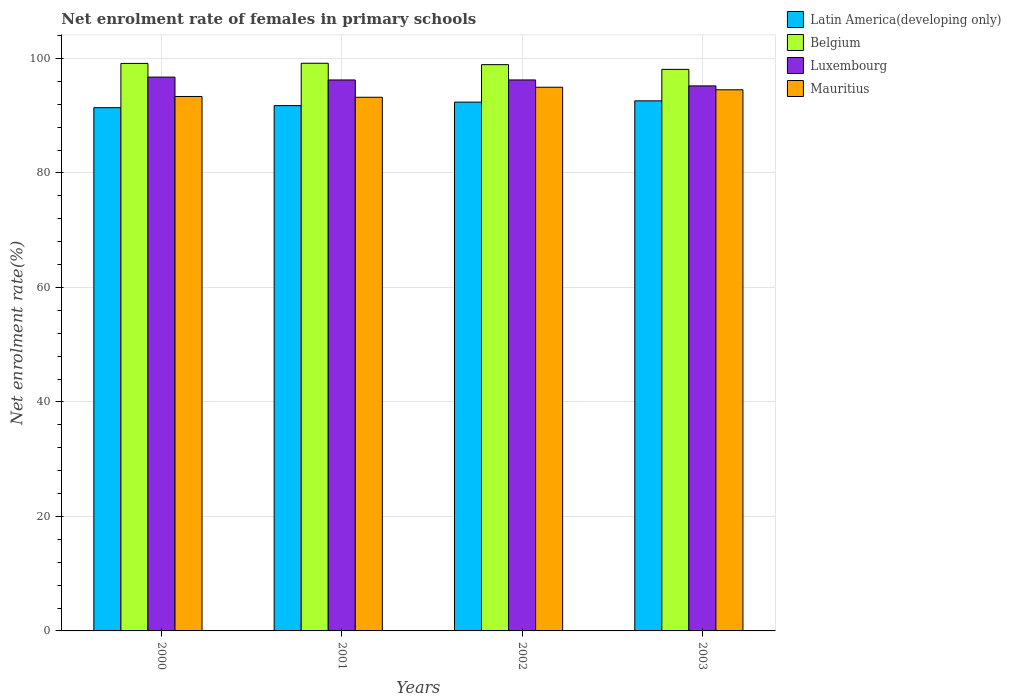Are the number of bars on each tick of the X-axis equal?
Your answer should be compact. Yes. What is the label of the 3rd group of bars from the left?
Offer a very short reply. 2002. In how many cases, is the number of bars for a given year not equal to the number of legend labels?
Provide a succinct answer. 0. What is the net enrolment rate of females in primary schools in Latin America(developing only) in 2001?
Make the answer very short. 91.77. Across all years, what is the maximum net enrolment rate of females in primary schools in Luxembourg?
Your answer should be compact. 96.75. Across all years, what is the minimum net enrolment rate of females in primary schools in Mauritius?
Offer a very short reply. 93.23. In which year was the net enrolment rate of females in primary schools in Mauritius minimum?
Provide a short and direct response. 2001. What is the total net enrolment rate of females in primary schools in Belgium in the graph?
Keep it short and to the point. 395.34. What is the difference between the net enrolment rate of females in primary schools in Mauritius in 2000 and that in 2002?
Make the answer very short. -1.61. What is the difference between the net enrolment rate of females in primary schools in Mauritius in 2000 and the net enrolment rate of females in primary schools in Luxembourg in 2003?
Your response must be concise. -1.85. What is the average net enrolment rate of females in primary schools in Mauritius per year?
Your response must be concise. 94.03. In the year 2002, what is the difference between the net enrolment rate of females in primary schools in Latin America(developing only) and net enrolment rate of females in primary schools in Luxembourg?
Your answer should be very brief. -3.88. In how many years, is the net enrolment rate of females in primary schools in Belgium greater than 24 %?
Ensure brevity in your answer.  4. What is the ratio of the net enrolment rate of females in primary schools in Belgium in 2001 to that in 2003?
Provide a short and direct response. 1.01. Is the difference between the net enrolment rate of females in primary schools in Latin America(developing only) in 2001 and 2003 greater than the difference between the net enrolment rate of females in primary schools in Luxembourg in 2001 and 2003?
Your answer should be compact. No. What is the difference between the highest and the second highest net enrolment rate of females in primary schools in Luxembourg?
Give a very brief answer. 0.5. What is the difference between the highest and the lowest net enrolment rate of females in primary schools in Luxembourg?
Your response must be concise. 1.54. Is the sum of the net enrolment rate of females in primary schools in Latin America(developing only) in 2000 and 2001 greater than the maximum net enrolment rate of females in primary schools in Luxembourg across all years?
Provide a short and direct response. Yes. Is it the case that in every year, the sum of the net enrolment rate of females in primary schools in Mauritius and net enrolment rate of females in primary schools in Belgium is greater than the sum of net enrolment rate of females in primary schools in Latin America(developing only) and net enrolment rate of females in primary schools in Luxembourg?
Your answer should be compact. Yes. What does the 1st bar from the left in 2003 represents?
Ensure brevity in your answer.  Latin America(developing only). What does the 4th bar from the right in 2003 represents?
Keep it short and to the point. Latin America(developing only). How many years are there in the graph?
Give a very brief answer. 4. What is the difference between two consecutive major ticks on the Y-axis?
Offer a very short reply. 20. Does the graph contain any zero values?
Offer a very short reply. No. Does the graph contain grids?
Provide a short and direct response. Yes. Where does the legend appear in the graph?
Give a very brief answer. Top right. What is the title of the graph?
Make the answer very short. Net enrolment rate of females in primary schools. What is the label or title of the X-axis?
Keep it short and to the point. Years. What is the label or title of the Y-axis?
Offer a very short reply. Net enrolment rate(%). What is the Net enrolment rate(%) in Latin America(developing only) in 2000?
Give a very brief answer. 91.41. What is the Net enrolment rate(%) in Belgium in 2000?
Provide a short and direct response. 99.14. What is the Net enrolment rate(%) in Luxembourg in 2000?
Your answer should be compact. 96.75. What is the Net enrolment rate(%) of Mauritius in 2000?
Ensure brevity in your answer.  93.36. What is the Net enrolment rate(%) in Latin America(developing only) in 2001?
Offer a very short reply. 91.77. What is the Net enrolment rate(%) of Belgium in 2001?
Your answer should be compact. 99.17. What is the Net enrolment rate(%) of Luxembourg in 2001?
Provide a succinct answer. 96.25. What is the Net enrolment rate(%) in Mauritius in 2001?
Your response must be concise. 93.23. What is the Net enrolment rate(%) in Latin America(developing only) in 2002?
Offer a very short reply. 92.38. What is the Net enrolment rate(%) in Belgium in 2002?
Your answer should be very brief. 98.93. What is the Net enrolment rate(%) in Luxembourg in 2002?
Make the answer very short. 96.25. What is the Net enrolment rate(%) of Mauritius in 2002?
Provide a short and direct response. 94.98. What is the Net enrolment rate(%) in Latin America(developing only) in 2003?
Offer a terse response. 92.6. What is the Net enrolment rate(%) of Belgium in 2003?
Your answer should be very brief. 98.1. What is the Net enrolment rate(%) in Luxembourg in 2003?
Ensure brevity in your answer.  95.21. What is the Net enrolment rate(%) in Mauritius in 2003?
Your answer should be very brief. 94.53. Across all years, what is the maximum Net enrolment rate(%) of Latin America(developing only)?
Offer a very short reply. 92.6. Across all years, what is the maximum Net enrolment rate(%) in Belgium?
Offer a very short reply. 99.17. Across all years, what is the maximum Net enrolment rate(%) of Luxembourg?
Offer a terse response. 96.75. Across all years, what is the maximum Net enrolment rate(%) in Mauritius?
Your answer should be compact. 94.98. Across all years, what is the minimum Net enrolment rate(%) of Latin America(developing only)?
Give a very brief answer. 91.41. Across all years, what is the minimum Net enrolment rate(%) in Belgium?
Provide a short and direct response. 98.1. Across all years, what is the minimum Net enrolment rate(%) of Luxembourg?
Offer a very short reply. 95.21. Across all years, what is the minimum Net enrolment rate(%) in Mauritius?
Provide a succinct answer. 93.23. What is the total Net enrolment rate(%) of Latin America(developing only) in the graph?
Your response must be concise. 368.15. What is the total Net enrolment rate(%) in Belgium in the graph?
Your answer should be compact. 395.34. What is the total Net enrolment rate(%) in Luxembourg in the graph?
Provide a short and direct response. 384.47. What is the total Net enrolment rate(%) of Mauritius in the graph?
Give a very brief answer. 376.11. What is the difference between the Net enrolment rate(%) of Latin America(developing only) in 2000 and that in 2001?
Your answer should be very brief. -0.36. What is the difference between the Net enrolment rate(%) in Belgium in 2000 and that in 2001?
Offer a very short reply. -0.03. What is the difference between the Net enrolment rate(%) of Luxembourg in 2000 and that in 2001?
Provide a short and direct response. 0.5. What is the difference between the Net enrolment rate(%) in Mauritius in 2000 and that in 2001?
Offer a terse response. 0.13. What is the difference between the Net enrolment rate(%) in Latin America(developing only) in 2000 and that in 2002?
Ensure brevity in your answer.  -0.97. What is the difference between the Net enrolment rate(%) of Belgium in 2000 and that in 2002?
Make the answer very short. 0.22. What is the difference between the Net enrolment rate(%) of Luxembourg in 2000 and that in 2002?
Keep it short and to the point. 0.5. What is the difference between the Net enrolment rate(%) of Mauritius in 2000 and that in 2002?
Give a very brief answer. -1.61. What is the difference between the Net enrolment rate(%) of Latin America(developing only) in 2000 and that in 2003?
Your answer should be compact. -1.2. What is the difference between the Net enrolment rate(%) in Belgium in 2000 and that in 2003?
Your answer should be very brief. 1.04. What is the difference between the Net enrolment rate(%) of Luxembourg in 2000 and that in 2003?
Offer a very short reply. 1.54. What is the difference between the Net enrolment rate(%) in Mauritius in 2000 and that in 2003?
Give a very brief answer. -1.17. What is the difference between the Net enrolment rate(%) in Latin America(developing only) in 2001 and that in 2002?
Provide a short and direct response. -0.61. What is the difference between the Net enrolment rate(%) in Belgium in 2001 and that in 2002?
Ensure brevity in your answer.  0.24. What is the difference between the Net enrolment rate(%) in Luxembourg in 2001 and that in 2002?
Offer a terse response. -0. What is the difference between the Net enrolment rate(%) in Mauritius in 2001 and that in 2002?
Offer a very short reply. -1.75. What is the difference between the Net enrolment rate(%) of Latin America(developing only) in 2001 and that in 2003?
Provide a short and direct response. -0.84. What is the difference between the Net enrolment rate(%) of Belgium in 2001 and that in 2003?
Provide a succinct answer. 1.07. What is the difference between the Net enrolment rate(%) in Luxembourg in 2001 and that in 2003?
Give a very brief answer. 1.04. What is the difference between the Net enrolment rate(%) in Mauritius in 2001 and that in 2003?
Your response must be concise. -1.3. What is the difference between the Net enrolment rate(%) in Latin America(developing only) in 2002 and that in 2003?
Provide a short and direct response. -0.22. What is the difference between the Net enrolment rate(%) of Belgium in 2002 and that in 2003?
Ensure brevity in your answer.  0.83. What is the difference between the Net enrolment rate(%) in Luxembourg in 2002 and that in 2003?
Your answer should be compact. 1.04. What is the difference between the Net enrolment rate(%) of Mauritius in 2002 and that in 2003?
Your answer should be compact. 0.44. What is the difference between the Net enrolment rate(%) of Latin America(developing only) in 2000 and the Net enrolment rate(%) of Belgium in 2001?
Your response must be concise. -7.76. What is the difference between the Net enrolment rate(%) in Latin America(developing only) in 2000 and the Net enrolment rate(%) in Luxembourg in 2001?
Provide a succinct answer. -4.85. What is the difference between the Net enrolment rate(%) of Latin America(developing only) in 2000 and the Net enrolment rate(%) of Mauritius in 2001?
Provide a succinct answer. -1.82. What is the difference between the Net enrolment rate(%) of Belgium in 2000 and the Net enrolment rate(%) of Luxembourg in 2001?
Provide a succinct answer. 2.89. What is the difference between the Net enrolment rate(%) of Belgium in 2000 and the Net enrolment rate(%) of Mauritius in 2001?
Your response must be concise. 5.91. What is the difference between the Net enrolment rate(%) of Luxembourg in 2000 and the Net enrolment rate(%) of Mauritius in 2001?
Provide a short and direct response. 3.52. What is the difference between the Net enrolment rate(%) of Latin America(developing only) in 2000 and the Net enrolment rate(%) of Belgium in 2002?
Your answer should be compact. -7.52. What is the difference between the Net enrolment rate(%) of Latin America(developing only) in 2000 and the Net enrolment rate(%) of Luxembourg in 2002?
Provide a succinct answer. -4.85. What is the difference between the Net enrolment rate(%) in Latin America(developing only) in 2000 and the Net enrolment rate(%) in Mauritius in 2002?
Your response must be concise. -3.57. What is the difference between the Net enrolment rate(%) of Belgium in 2000 and the Net enrolment rate(%) of Luxembourg in 2002?
Give a very brief answer. 2.89. What is the difference between the Net enrolment rate(%) of Belgium in 2000 and the Net enrolment rate(%) of Mauritius in 2002?
Ensure brevity in your answer.  4.16. What is the difference between the Net enrolment rate(%) of Luxembourg in 2000 and the Net enrolment rate(%) of Mauritius in 2002?
Your response must be concise. 1.77. What is the difference between the Net enrolment rate(%) in Latin America(developing only) in 2000 and the Net enrolment rate(%) in Belgium in 2003?
Provide a succinct answer. -6.7. What is the difference between the Net enrolment rate(%) in Latin America(developing only) in 2000 and the Net enrolment rate(%) in Luxembourg in 2003?
Provide a succinct answer. -3.81. What is the difference between the Net enrolment rate(%) in Latin America(developing only) in 2000 and the Net enrolment rate(%) in Mauritius in 2003?
Keep it short and to the point. -3.13. What is the difference between the Net enrolment rate(%) of Belgium in 2000 and the Net enrolment rate(%) of Luxembourg in 2003?
Your response must be concise. 3.93. What is the difference between the Net enrolment rate(%) of Belgium in 2000 and the Net enrolment rate(%) of Mauritius in 2003?
Your response must be concise. 4.61. What is the difference between the Net enrolment rate(%) in Luxembourg in 2000 and the Net enrolment rate(%) in Mauritius in 2003?
Keep it short and to the point. 2.21. What is the difference between the Net enrolment rate(%) in Latin America(developing only) in 2001 and the Net enrolment rate(%) in Belgium in 2002?
Your answer should be very brief. -7.16. What is the difference between the Net enrolment rate(%) in Latin America(developing only) in 2001 and the Net enrolment rate(%) in Luxembourg in 2002?
Keep it short and to the point. -4.49. What is the difference between the Net enrolment rate(%) of Latin America(developing only) in 2001 and the Net enrolment rate(%) of Mauritius in 2002?
Offer a very short reply. -3.21. What is the difference between the Net enrolment rate(%) in Belgium in 2001 and the Net enrolment rate(%) in Luxembourg in 2002?
Make the answer very short. 2.92. What is the difference between the Net enrolment rate(%) in Belgium in 2001 and the Net enrolment rate(%) in Mauritius in 2002?
Your answer should be compact. 4.19. What is the difference between the Net enrolment rate(%) in Luxembourg in 2001 and the Net enrolment rate(%) in Mauritius in 2002?
Give a very brief answer. 1.27. What is the difference between the Net enrolment rate(%) of Latin America(developing only) in 2001 and the Net enrolment rate(%) of Belgium in 2003?
Your response must be concise. -6.34. What is the difference between the Net enrolment rate(%) of Latin America(developing only) in 2001 and the Net enrolment rate(%) of Luxembourg in 2003?
Your answer should be very brief. -3.45. What is the difference between the Net enrolment rate(%) of Latin America(developing only) in 2001 and the Net enrolment rate(%) of Mauritius in 2003?
Keep it short and to the point. -2.77. What is the difference between the Net enrolment rate(%) of Belgium in 2001 and the Net enrolment rate(%) of Luxembourg in 2003?
Offer a very short reply. 3.95. What is the difference between the Net enrolment rate(%) in Belgium in 2001 and the Net enrolment rate(%) in Mauritius in 2003?
Give a very brief answer. 4.63. What is the difference between the Net enrolment rate(%) of Luxembourg in 2001 and the Net enrolment rate(%) of Mauritius in 2003?
Your answer should be compact. 1.72. What is the difference between the Net enrolment rate(%) in Latin America(developing only) in 2002 and the Net enrolment rate(%) in Belgium in 2003?
Provide a short and direct response. -5.72. What is the difference between the Net enrolment rate(%) of Latin America(developing only) in 2002 and the Net enrolment rate(%) of Luxembourg in 2003?
Keep it short and to the point. -2.84. What is the difference between the Net enrolment rate(%) of Latin America(developing only) in 2002 and the Net enrolment rate(%) of Mauritius in 2003?
Provide a succinct answer. -2.16. What is the difference between the Net enrolment rate(%) of Belgium in 2002 and the Net enrolment rate(%) of Luxembourg in 2003?
Make the answer very short. 3.71. What is the difference between the Net enrolment rate(%) of Belgium in 2002 and the Net enrolment rate(%) of Mauritius in 2003?
Provide a short and direct response. 4.39. What is the difference between the Net enrolment rate(%) of Luxembourg in 2002 and the Net enrolment rate(%) of Mauritius in 2003?
Make the answer very short. 1.72. What is the average Net enrolment rate(%) in Latin America(developing only) per year?
Give a very brief answer. 92.04. What is the average Net enrolment rate(%) of Belgium per year?
Provide a short and direct response. 98.83. What is the average Net enrolment rate(%) of Luxembourg per year?
Your answer should be compact. 96.12. What is the average Net enrolment rate(%) in Mauritius per year?
Your answer should be very brief. 94.03. In the year 2000, what is the difference between the Net enrolment rate(%) of Latin America(developing only) and Net enrolment rate(%) of Belgium?
Offer a very short reply. -7.74. In the year 2000, what is the difference between the Net enrolment rate(%) in Latin America(developing only) and Net enrolment rate(%) in Luxembourg?
Make the answer very short. -5.34. In the year 2000, what is the difference between the Net enrolment rate(%) of Latin America(developing only) and Net enrolment rate(%) of Mauritius?
Provide a short and direct response. -1.96. In the year 2000, what is the difference between the Net enrolment rate(%) of Belgium and Net enrolment rate(%) of Luxembourg?
Make the answer very short. 2.39. In the year 2000, what is the difference between the Net enrolment rate(%) of Belgium and Net enrolment rate(%) of Mauritius?
Ensure brevity in your answer.  5.78. In the year 2000, what is the difference between the Net enrolment rate(%) in Luxembourg and Net enrolment rate(%) in Mauritius?
Make the answer very short. 3.38. In the year 2001, what is the difference between the Net enrolment rate(%) in Latin America(developing only) and Net enrolment rate(%) in Belgium?
Your answer should be very brief. -7.4. In the year 2001, what is the difference between the Net enrolment rate(%) of Latin America(developing only) and Net enrolment rate(%) of Luxembourg?
Your response must be concise. -4.49. In the year 2001, what is the difference between the Net enrolment rate(%) in Latin America(developing only) and Net enrolment rate(%) in Mauritius?
Make the answer very short. -1.46. In the year 2001, what is the difference between the Net enrolment rate(%) of Belgium and Net enrolment rate(%) of Luxembourg?
Make the answer very short. 2.92. In the year 2001, what is the difference between the Net enrolment rate(%) of Belgium and Net enrolment rate(%) of Mauritius?
Your answer should be compact. 5.94. In the year 2001, what is the difference between the Net enrolment rate(%) in Luxembourg and Net enrolment rate(%) in Mauritius?
Provide a succinct answer. 3.02. In the year 2002, what is the difference between the Net enrolment rate(%) of Latin America(developing only) and Net enrolment rate(%) of Belgium?
Your answer should be compact. -6.55. In the year 2002, what is the difference between the Net enrolment rate(%) in Latin America(developing only) and Net enrolment rate(%) in Luxembourg?
Keep it short and to the point. -3.88. In the year 2002, what is the difference between the Net enrolment rate(%) in Latin America(developing only) and Net enrolment rate(%) in Mauritius?
Give a very brief answer. -2.6. In the year 2002, what is the difference between the Net enrolment rate(%) in Belgium and Net enrolment rate(%) in Luxembourg?
Give a very brief answer. 2.67. In the year 2002, what is the difference between the Net enrolment rate(%) of Belgium and Net enrolment rate(%) of Mauritius?
Offer a terse response. 3.95. In the year 2002, what is the difference between the Net enrolment rate(%) of Luxembourg and Net enrolment rate(%) of Mauritius?
Ensure brevity in your answer.  1.27. In the year 2003, what is the difference between the Net enrolment rate(%) in Latin America(developing only) and Net enrolment rate(%) in Belgium?
Make the answer very short. -5.5. In the year 2003, what is the difference between the Net enrolment rate(%) of Latin America(developing only) and Net enrolment rate(%) of Luxembourg?
Offer a terse response. -2.61. In the year 2003, what is the difference between the Net enrolment rate(%) of Latin America(developing only) and Net enrolment rate(%) of Mauritius?
Your response must be concise. -1.93. In the year 2003, what is the difference between the Net enrolment rate(%) in Belgium and Net enrolment rate(%) in Luxembourg?
Your answer should be compact. 2.89. In the year 2003, what is the difference between the Net enrolment rate(%) of Belgium and Net enrolment rate(%) of Mauritius?
Offer a terse response. 3.57. In the year 2003, what is the difference between the Net enrolment rate(%) of Luxembourg and Net enrolment rate(%) of Mauritius?
Provide a succinct answer. 0.68. What is the ratio of the Net enrolment rate(%) of Latin America(developing only) in 2000 to that in 2001?
Ensure brevity in your answer.  1. What is the ratio of the Net enrolment rate(%) of Latin America(developing only) in 2000 to that in 2002?
Keep it short and to the point. 0.99. What is the ratio of the Net enrolment rate(%) of Belgium in 2000 to that in 2002?
Your answer should be very brief. 1. What is the ratio of the Net enrolment rate(%) in Mauritius in 2000 to that in 2002?
Your answer should be compact. 0.98. What is the ratio of the Net enrolment rate(%) of Latin America(developing only) in 2000 to that in 2003?
Give a very brief answer. 0.99. What is the ratio of the Net enrolment rate(%) of Belgium in 2000 to that in 2003?
Give a very brief answer. 1.01. What is the ratio of the Net enrolment rate(%) in Luxembourg in 2000 to that in 2003?
Make the answer very short. 1.02. What is the ratio of the Net enrolment rate(%) in Mauritius in 2000 to that in 2003?
Give a very brief answer. 0.99. What is the ratio of the Net enrolment rate(%) of Belgium in 2001 to that in 2002?
Your answer should be very brief. 1. What is the ratio of the Net enrolment rate(%) in Mauritius in 2001 to that in 2002?
Offer a very short reply. 0.98. What is the ratio of the Net enrolment rate(%) in Belgium in 2001 to that in 2003?
Ensure brevity in your answer.  1.01. What is the ratio of the Net enrolment rate(%) in Luxembourg in 2001 to that in 2003?
Your answer should be compact. 1.01. What is the ratio of the Net enrolment rate(%) of Mauritius in 2001 to that in 2003?
Give a very brief answer. 0.99. What is the ratio of the Net enrolment rate(%) of Latin America(developing only) in 2002 to that in 2003?
Your answer should be compact. 1. What is the ratio of the Net enrolment rate(%) in Belgium in 2002 to that in 2003?
Make the answer very short. 1.01. What is the ratio of the Net enrolment rate(%) in Luxembourg in 2002 to that in 2003?
Provide a succinct answer. 1.01. What is the difference between the highest and the second highest Net enrolment rate(%) in Latin America(developing only)?
Give a very brief answer. 0.22. What is the difference between the highest and the second highest Net enrolment rate(%) of Belgium?
Ensure brevity in your answer.  0.03. What is the difference between the highest and the second highest Net enrolment rate(%) of Luxembourg?
Offer a terse response. 0.5. What is the difference between the highest and the second highest Net enrolment rate(%) in Mauritius?
Your answer should be very brief. 0.44. What is the difference between the highest and the lowest Net enrolment rate(%) of Latin America(developing only)?
Ensure brevity in your answer.  1.2. What is the difference between the highest and the lowest Net enrolment rate(%) in Belgium?
Your answer should be very brief. 1.07. What is the difference between the highest and the lowest Net enrolment rate(%) in Luxembourg?
Provide a short and direct response. 1.54. What is the difference between the highest and the lowest Net enrolment rate(%) in Mauritius?
Make the answer very short. 1.75. 